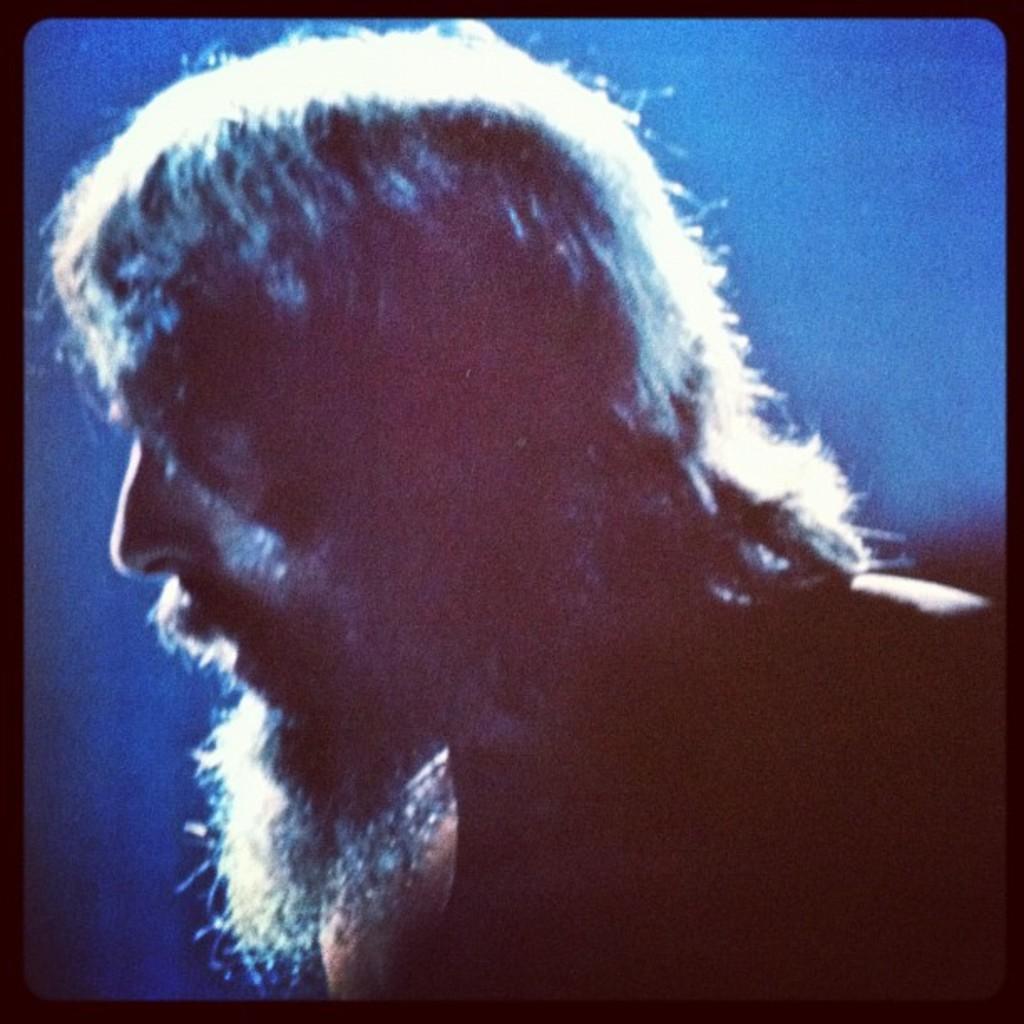Describe this image in one or two sentences. This image consists of a picture of a man. He is having white beard and white hair. The background is blue in color. 